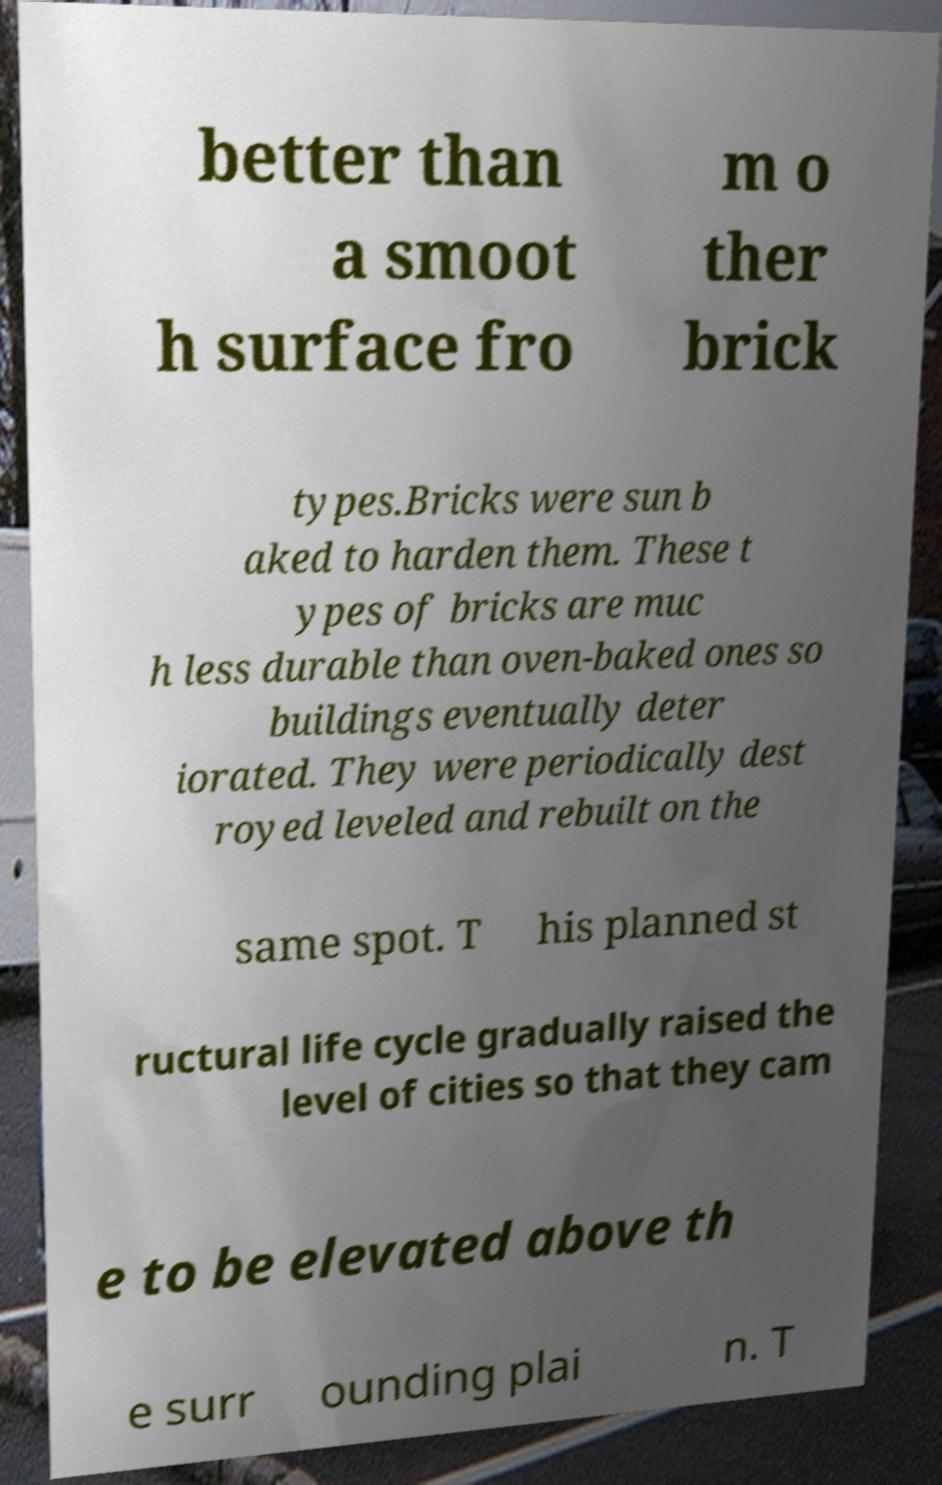Could you extract and type out the text from this image? better than a smoot h surface fro m o ther brick types.Bricks were sun b aked to harden them. These t ypes of bricks are muc h less durable than oven-baked ones so buildings eventually deter iorated. They were periodically dest royed leveled and rebuilt on the same spot. T his planned st ructural life cycle gradually raised the level of cities so that they cam e to be elevated above th e surr ounding plai n. T 